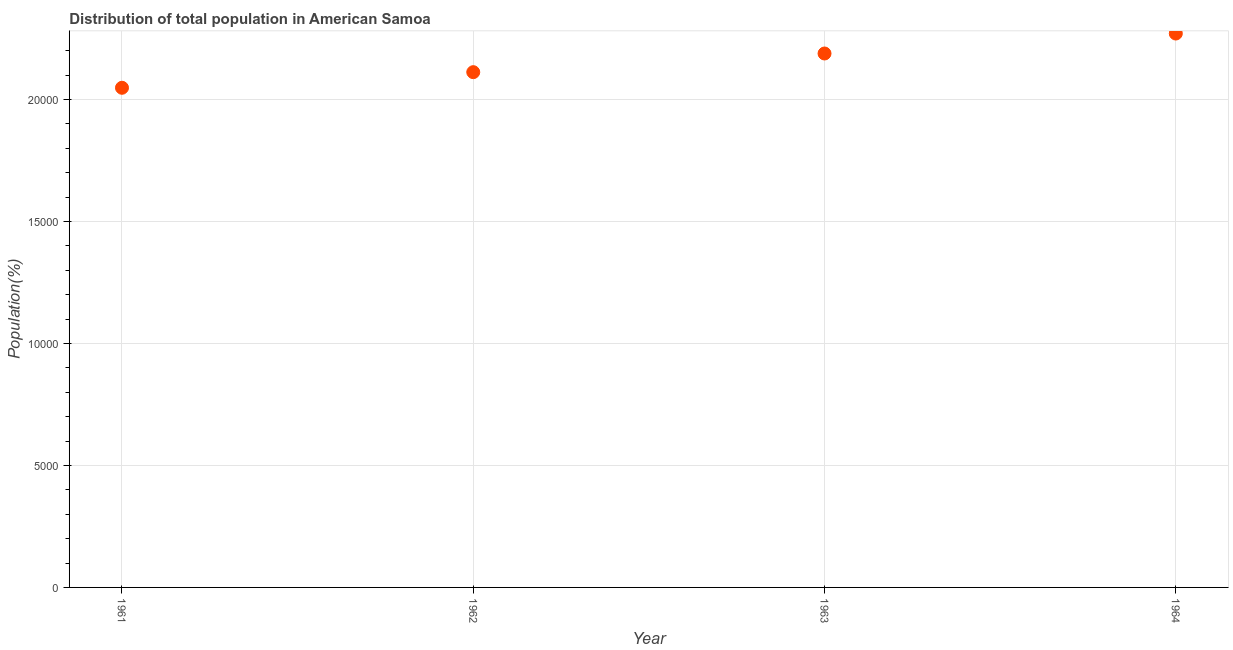What is the population in 1963?
Offer a terse response. 2.19e+04. Across all years, what is the maximum population?
Offer a very short reply. 2.27e+04. Across all years, what is the minimum population?
Provide a succinct answer. 2.05e+04. In which year was the population maximum?
Offer a terse response. 1964. What is the sum of the population?
Offer a very short reply. 8.62e+04. What is the difference between the population in 1962 and 1964?
Keep it short and to the point. -1583. What is the average population per year?
Provide a succinct answer. 2.15e+04. What is the median population?
Give a very brief answer. 2.15e+04. What is the ratio of the population in 1962 to that in 1963?
Provide a succinct answer. 0.97. Is the population in 1961 less than that in 1963?
Provide a succinct answer. Yes. What is the difference between the highest and the second highest population?
Your answer should be compact. 818. What is the difference between the highest and the lowest population?
Your response must be concise. 2223. How many dotlines are there?
Make the answer very short. 1. How many years are there in the graph?
Provide a short and direct response. 4. What is the difference between two consecutive major ticks on the Y-axis?
Give a very brief answer. 5000. Does the graph contain any zero values?
Your answer should be compact. No. Does the graph contain grids?
Offer a very short reply. Yes. What is the title of the graph?
Give a very brief answer. Distribution of total population in American Samoa . What is the label or title of the Y-axis?
Your answer should be compact. Population(%). What is the Population(%) in 1961?
Your answer should be compact. 2.05e+04. What is the Population(%) in 1962?
Offer a very short reply. 2.11e+04. What is the Population(%) in 1963?
Provide a short and direct response. 2.19e+04. What is the Population(%) in 1964?
Give a very brief answer. 2.27e+04. What is the difference between the Population(%) in 1961 and 1962?
Offer a terse response. -640. What is the difference between the Population(%) in 1961 and 1963?
Make the answer very short. -1405. What is the difference between the Population(%) in 1961 and 1964?
Your answer should be very brief. -2223. What is the difference between the Population(%) in 1962 and 1963?
Provide a succinct answer. -765. What is the difference between the Population(%) in 1962 and 1964?
Offer a terse response. -1583. What is the difference between the Population(%) in 1963 and 1964?
Provide a short and direct response. -818. What is the ratio of the Population(%) in 1961 to that in 1963?
Your answer should be very brief. 0.94. What is the ratio of the Population(%) in 1961 to that in 1964?
Offer a terse response. 0.9. What is the ratio of the Population(%) in 1962 to that in 1963?
Provide a succinct answer. 0.96. What is the ratio of the Population(%) in 1962 to that in 1964?
Keep it short and to the point. 0.93. 